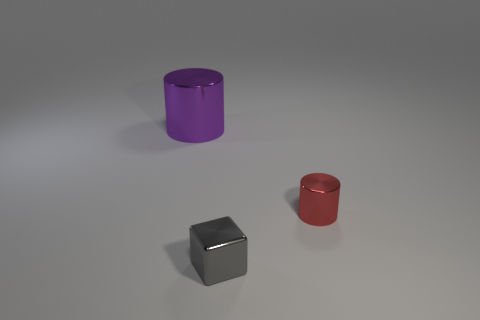Do the gray metal thing and the metal cylinder in front of the purple cylinder have the same size?
Keep it short and to the point. Yes. How many red things have the same size as the gray metallic thing?
Your answer should be compact. 1. How many big objects are metal cylinders or gray metal things?
Provide a short and direct response. 1. Is there a brown matte cylinder?
Your response must be concise. No. Are there more small gray cubes that are behind the tiny red object than metallic things to the left of the gray block?
Ensure brevity in your answer.  No. The metallic cylinder that is to the right of the metallic object behind the red metallic object is what color?
Your response must be concise. Red. Is there a large thing of the same color as the metal block?
Your answer should be compact. No. What size is the object behind the cylinder that is in front of the shiny cylinder on the left side of the small gray metallic cube?
Provide a short and direct response. Large. There is a tiny gray shiny thing; what shape is it?
Keep it short and to the point. Cube. How many big objects are to the left of the shiny cylinder in front of the big purple metal cylinder?
Keep it short and to the point. 1. 